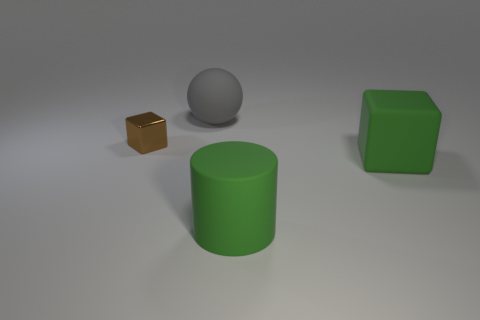Subtract all yellow blocks. Subtract all yellow balls. How many blocks are left? 2 Subtract all brown cylinders. How many cyan cubes are left? 0 Add 4 large greens. How many things exist? 0 Subtract all big gray matte spheres. Subtract all green cubes. How many objects are left? 2 Add 1 brown metal cubes. How many brown metal cubes are left? 2 Add 1 matte cylinders. How many matte cylinders exist? 2 Add 3 large gray objects. How many objects exist? 7 Subtract all brown cubes. How many cubes are left? 1 Subtract 0 purple cylinders. How many objects are left? 4 Subtract all balls. How many objects are left? 3 